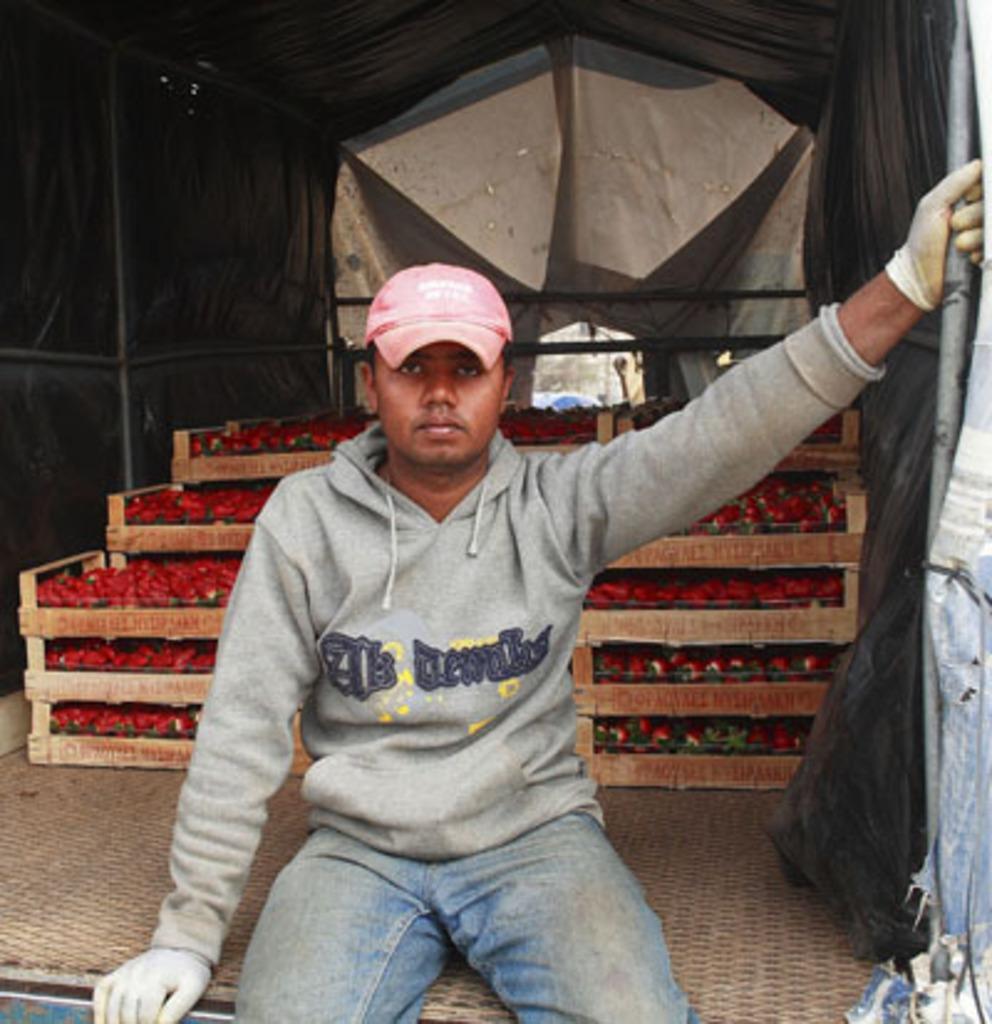Please provide a concise description of this image. The picture consists of a truck. In the foreground of the picture there is a person sitting in the truck, behind him there are strawberry trays. 